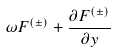<formula> <loc_0><loc_0><loc_500><loc_500>\omega F ^ { ( \pm ) } + \frac { \partial F ^ { ( \pm ) } } { \partial y }</formula> 